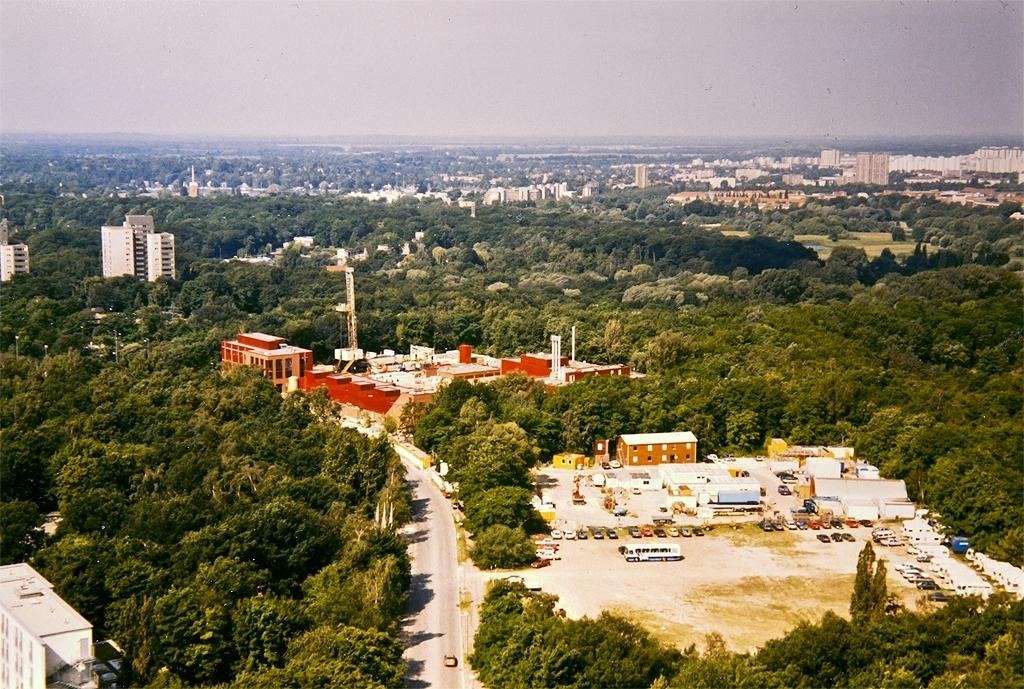What type of natural vegetation can be seen in the image? There are trees in the image. What type of man-made structures are present in the image? There are buildings in the image. What type of transportation is visible in the image? There are vehicles in the image. What is the primary surface for transportation in the image? There is a road in the image. What part of the natural environment is visible in the image? The sky is visible in the image. Can you tell me how the beast is swimming in the image? There is no beast present in the image, and therefore no such activity can be observed. What type of record can be seen being played in the image? There is no record being played in the image. 